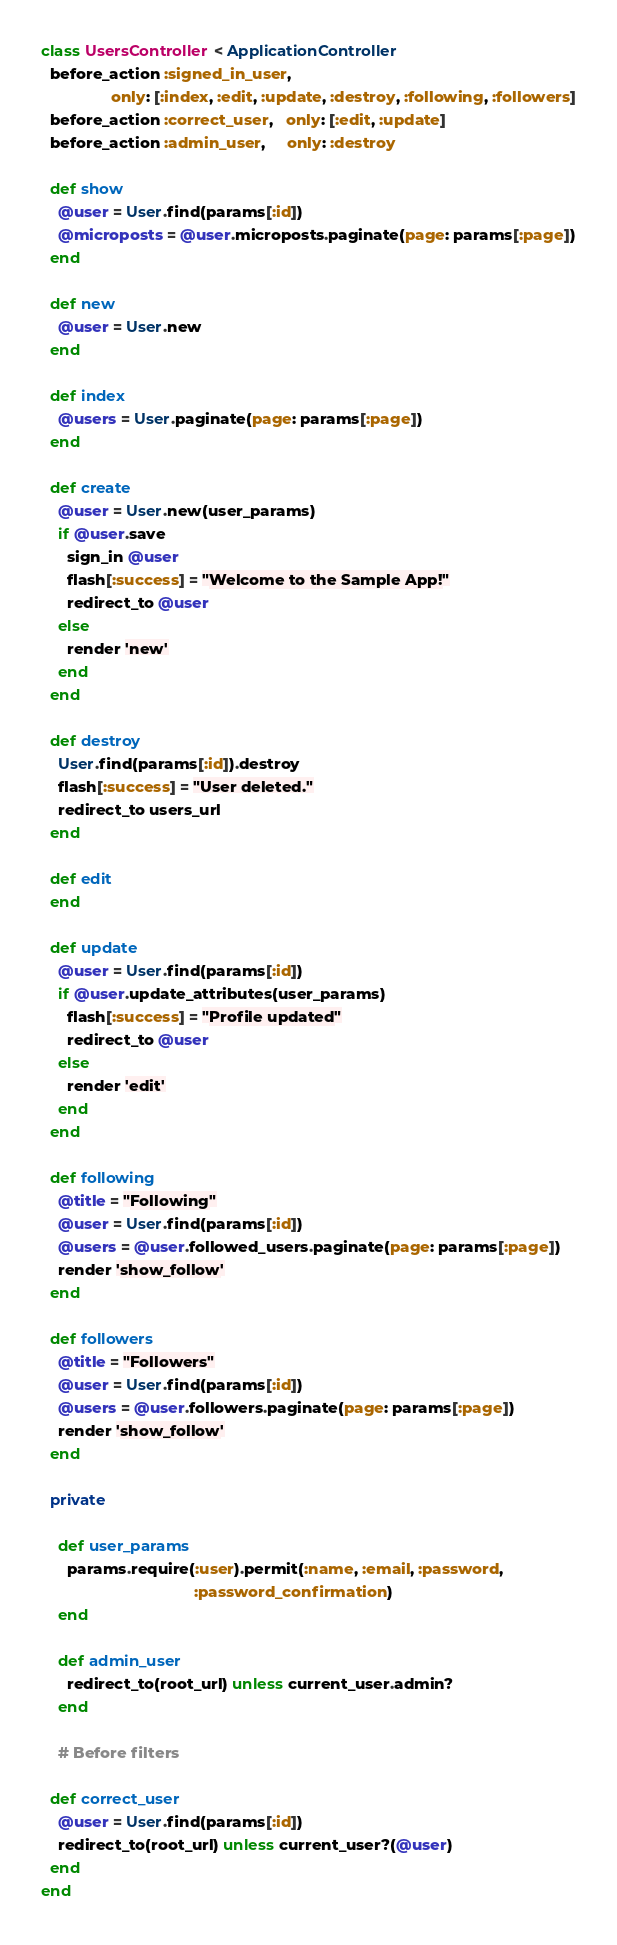Convert code to text. <code><loc_0><loc_0><loc_500><loc_500><_Ruby_>class UsersController < ApplicationController
  before_action :signed_in_user,
                only: [:index, :edit, :update, :destroy, :following, :followers]
  before_action :correct_user,   only: [:edit, :update]
  before_action :admin_user,     only: :destroy

  def show
    @user = User.find(params[:id])
    @microposts = @user.microposts.paginate(page: params[:page])
  end

  def new
    @user = User.new
  end

  def index
    @users = User.paginate(page: params[:page])
  end

  def create
    @user = User.new(user_params)
    if @user.save
      sign_in @user
      flash[:success] = "Welcome to the Sample App!"
      redirect_to @user
    else
      render 'new'
    end
  end

  def destroy
    User.find(params[:id]).destroy
    flash[:success] = "User deleted."
    redirect_to users_url
  end

  def edit
  end

  def update
    @user = User.find(params[:id])
    if @user.update_attributes(user_params)
      flash[:success] = "Profile updated"
      redirect_to @user
    else
      render 'edit'
    end
  end

  def following
    @title = "Following"
    @user = User.find(params[:id])
    @users = @user.followed_users.paginate(page: params[:page])
    render 'show_follow'
  end

  def followers
    @title = "Followers"
    @user = User.find(params[:id])
    @users = @user.followers.paginate(page: params[:page])
    render 'show_follow'
  end

  private

    def user_params
      params.require(:user).permit(:name, :email, :password,
                                   :password_confirmation)
    end

    def admin_user
      redirect_to(root_url) unless current_user.admin?
    end

    # Before filters

  def correct_user
    @user = User.find(params[:id])
    redirect_to(root_url) unless current_user?(@user)
  end
end
</code> 